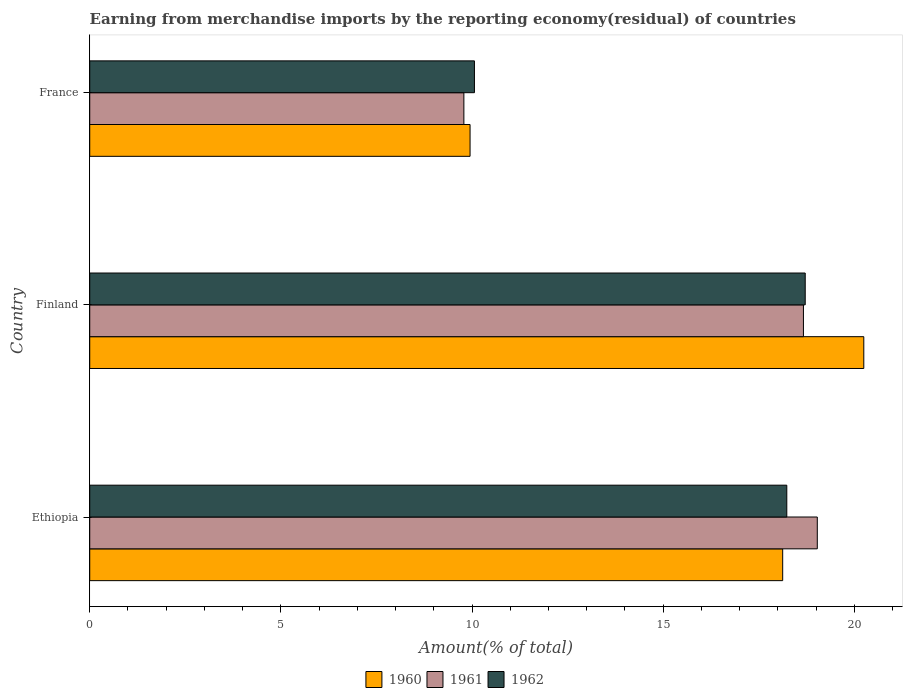How many different coloured bars are there?
Your answer should be very brief. 3. How many bars are there on the 3rd tick from the top?
Give a very brief answer. 3. In how many cases, is the number of bars for a given country not equal to the number of legend labels?
Provide a succinct answer. 0. What is the percentage of amount earned from merchandise imports in 1961 in France?
Give a very brief answer. 9.79. Across all countries, what is the maximum percentage of amount earned from merchandise imports in 1961?
Your answer should be very brief. 19.03. Across all countries, what is the minimum percentage of amount earned from merchandise imports in 1962?
Offer a very short reply. 10.06. In which country was the percentage of amount earned from merchandise imports in 1960 maximum?
Keep it short and to the point. Finland. What is the total percentage of amount earned from merchandise imports in 1961 in the graph?
Give a very brief answer. 47.49. What is the difference between the percentage of amount earned from merchandise imports in 1960 in Ethiopia and that in France?
Provide a succinct answer. 8.18. What is the difference between the percentage of amount earned from merchandise imports in 1960 in Finland and the percentage of amount earned from merchandise imports in 1962 in France?
Provide a short and direct response. 10.18. What is the average percentage of amount earned from merchandise imports in 1960 per country?
Keep it short and to the point. 16.11. What is the difference between the percentage of amount earned from merchandise imports in 1962 and percentage of amount earned from merchandise imports in 1961 in Ethiopia?
Your answer should be very brief. -0.8. In how many countries, is the percentage of amount earned from merchandise imports in 1961 greater than 9 %?
Provide a short and direct response. 3. What is the ratio of the percentage of amount earned from merchandise imports in 1961 in Ethiopia to that in France?
Make the answer very short. 1.94. Is the difference between the percentage of amount earned from merchandise imports in 1962 in Ethiopia and France greater than the difference between the percentage of amount earned from merchandise imports in 1961 in Ethiopia and France?
Provide a short and direct response. No. What is the difference between the highest and the second highest percentage of amount earned from merchandise imports in 1961?
Your response must be concise. 0.36. What is the difference between the highest and the lowest percentage of amount earned from merchandise imports in 1961?
Keep it short and to the point. 9.24. In how many countries, is the percentage of amount earned from merchandise imports in 1962 greater than the average percentage of amount earned from merchandise imports in 1962 taken over all countries?
Your response must be concise. 2. Is the sum of the percentage of amount earned from merchandise imports in 1961 in Ethiopia and Finland greater than the maximum percentage of amount earned from merchandise imports in 1962 across all countries?
Provide a succinct answer. Yes. What does the 2nd bar from the top in France represents?
Give a very brief answer. 1961. Are all the bars in the graph horizontal?
Your answer should be compact. Yes. Are the values on the major ticks of X-axis written in scientific E-notation?
Offer a very short reply. No. Does the graph contain any zero values?
Your response must be concise. No. Does the graph contain grids?
Your answer should be very brief. No. Where does the legend appear in the graph?
Your answer should be compact. Bottom center. How many legend labels are there?
Provide a succinct answer. 3. What is the title of the graph?
Provide a short and direct response. Earning from merchandise imports by the reporting economy(residual) of countries. Does "1989" appear as one of the legend labels in the graph?
Your answer should be very brief. No. What is the label or title of the X-axis?
Offer a very short reply. Amount(% of total). What is the label or title of the Y-axis?
Provide a short and direct response. Country. What is the Amount(% of total) of 1960 in Ethiopia?
Keep it short and to the point. 18.13. What is the Amount(% of total) of 1961 in Ethiopia?
Provide a short and direct response. 19.03. What is the Amount(% of total) of 1962 in Ethiopia?
Your response must be concise. 18.23. What is the Amount(% of total) of 1960 in Finland?
Your answer should be compact. 20.25. What is the Amount(% of total) of 1961 in Finland?
Give a very brief answer. 18.67. What is the Amount(% of total) of 1962 in Finland?
Your response must be concise. 18.72. What is the Amount(% of total) in 1960 in France?
Provide a short and direct response. 9.95. What is the Amount(% of total) of 1961 in France?
Offer a terse response. 9.79. What is the Amount(% of total) in 1962 in France?
Provide a short and direct response. 10.06. Across all countries, what is the maximum Amount(% of total) of 1960?
Make the answer very short. 20.25. Across all countries, what is the maximum Amount(% of total) in 1961?
Keep it short and to the point. 19.03. Across all countries, what is the maximum Amount(% of total) in 1962?
Offer a terse response. 18.72. Across all countries, what is the minimum Amount(% of total) in 1960?
Give a very brief answer. 9.95. Across all countries, what is the minimum Amount(% of total) of 1961?
Offer a very short reply. 9.79. Across all countries, what is the minimum Amount(% of total) in 1962?
Keep it short and to the point. 10.06. What is the total Amount(% of total) in 1960 in the graph?
Give a very brief answer. 48.33. What is the total Amount(% of total) in 1961 in the graph?
Your response must be concise. 47.49. What is the total Amount(% of total) in 1962 in the graph?
Give a very brief answer. 47.01. What is the difference between the Amount(% of total) of 1960 in Ethiopia and that in Finland?
Your answer should be very brief. -2.12. What is the difference between the Amount(% of total) in 1961 in Ethiopia and that in Finland?
Keep it short and to the point. 0.36. What is the difference between the Amount(% of total) of 1962 in Ethiopia and that in Finland?
Offer a very short reply. -0.48. What is the difference between the Amount(% of total) in 1960 in Ethiopia and that in France?
Give a very brief answer. 8.18. What is the difference between the Amount(% of total) in 1961 in Ethiopia and that in France?
Give a very brief answer. 9.24. What is the difference between the Amount(% of total) of 1962 in Ethiopia and that in France?
Make the answer very short. 8.17. What is the difference between the Amount(% of total) of 1960 in Finland and that in France?
Your response must be concise. 10.3. What is the difference between the Amount(% of total) of 1961 in Finland and that in France?
Provide a succinct answer. 8.88. What is the difference between the Amount(% of total) of 1962 in Finland and that in France?
Provide a succinct answer. 8.65. What is the difference between the Amount(% of total) in 1960 in Ethiopia and the Amount(% of total) in 1961 in Finland?
Provide a succinct answer. -0.54. What is the difference between the Amount(% of total) in 1960 in Ethiopia and the Amount(% of total) in 1962 in Finland?
Offer a very short reply. -0.59. What is the difference between the Amount(% of total) in 1961 in Ethiopia and the Amount(% of total) in 1962 in Finland?
Keep it short and to the point. 0.32. What is the difference between the Amount(% of total) of 1960 in Ethiopia and the Amount(% of total) of 1961 in France?
Keep it short and to the point. 8.34. What is the difference between the Amount(% of total) of 1960 in Ethiopia and the Amount(% of total) of 1962 in France?
Offer a terse response. 8.06. What is the difference between the Amount(% of total) of 1961 in Ethiopia and the Amount(% of total) of 1962 in France?
Your answer should be compact. 8.97. What is the difference between the Amount(% of total) of 1960 in Finland and the Amount(% of total) of 1961 in France?
Your answer should be compact. 10.46. What is the difference between the Amount(% of total) in 1960 in Finland and the Amount(% of total) in 1962 in France?
Offer a very short reply. 10.19. What is the difference between the Amount(% of total) of 1961 in Finland and the Amount(% of total) of 1962 in France?
Provide a succinct answer. 8.61. What is the average Amount(% of total) in 1960 per country?
Ensure brevity in your answer.  16.11. What is the average Amount(% of total) of 1961 per country?
Give a very brief answer. 15.83. What is the average Amount(% of total) of 1962 per country?
Offer a very short reply. 15.67. What is the difference between the Amount(% of total) in 1960 and Amount(% of total) in 1961 in Ethiopia?
Your response must be concise. -0.91. What is the difference between the Amount(% of total) in 1960 and Amount(% of total) in 1962 in Ethiopia?
Give a very brief answer. -0.11. What is the difference between the Amount(% of total) of 1961 and Amount(% of total) of 1962 in Ethiopia?
Give a very brief answer. 0.8. What is the difference between the Amount(% of total) of 1960 and Amount(% of total) of 1961 in Finland?
Make the answer very short. 1.58. What is the difference between the Amount(% of total) of 1960 and Amount(% of total) of 1962 in Finland?
Provide a short and direct response. 1.53. What is the difference between the Amount(% of total) of 1961 and Amount(% of total) of 1962 in Finland?
Ensure brevity in your answer.  -0.05. What is the difference between the Amount(% of total) of 1960 and Amount(% of total) of 1961 in France?
Your answer should be very brief. 0.16. What is the difference between the Amount(% of total) of 1960 and Amount(% of total) of 1962 in France?
Offer a terse response. -0.11. What is the difference between the Amount(% of total) in 1961 and Amount(% of total) in 1962 in France?
Provide a succinct answer. -0.28. What is the ratio of the Amount(% of total) in 1960 in Ethiopia to that in Finland?
Your answer should be compact. 0.9. What is the ratio of the Amount(% of total) of 1961 in Ethiopia to that in Finland?
Ensure brevity in your answer.  1.02. What is the ratio of the Amount(% of total) of 1962 in Ethiopia to that in Finland?
Offer a very short reply. 0.97. What is the ratio of the Amount(% of total) in 1960 in Ethiopia to that in France?
Offer a very short reply. 1.82. What is the ratio of the Amount(% of total) in 1961 in Ethiopia to that in France?
Offer a terse response. 1.94. What is the ratio of the Amount(% of total) of 1962 in Ethiopia to that in France?
Your response must be concise. 1.81. What is the ratio of the Amount(% of total) of 1960 in Finland to that in France?
Your answer should be very brief. 2.04. What is the ratio of the Amount(% of total) in 1961 in Finland to that in France?
Your answer should be compact. 1.91. What is the ratio of the Amount(% of total) in 1962 in Finland to that in France?
Ensure brevity in your answer.  1.86. What is the difference between the highest and the second highest Amount(% of total) in 1960?
Make the answer very short. 2.12. What is the difference between the highest and the second highest Amount(% of total) of 1961?
Your response must be concise. 0.36. What is the difference between the highest and the second highest Amount(% of total) of 1962?
Your answer should be very brief. 0.48. What is the difference between the highest and the lowest Amount(% of total) in 1960?
Provide a succinct answer. 10.3. What is the difference between the highest and the lowest Amount(% of total) in 1961?
Your answer should be compact. 9.24. What is the difference between the highest and the lowest Amount(% of total) in 1962?
Make the answer very short. 8.65. 